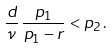<formula> <loc_0><loc_0><loc_500><loc_500>\frac { d } { \nu } \, \frac { p _ { 1 } } { p _ { 1 } - r } < p _ { 2 } \, .</formula> 